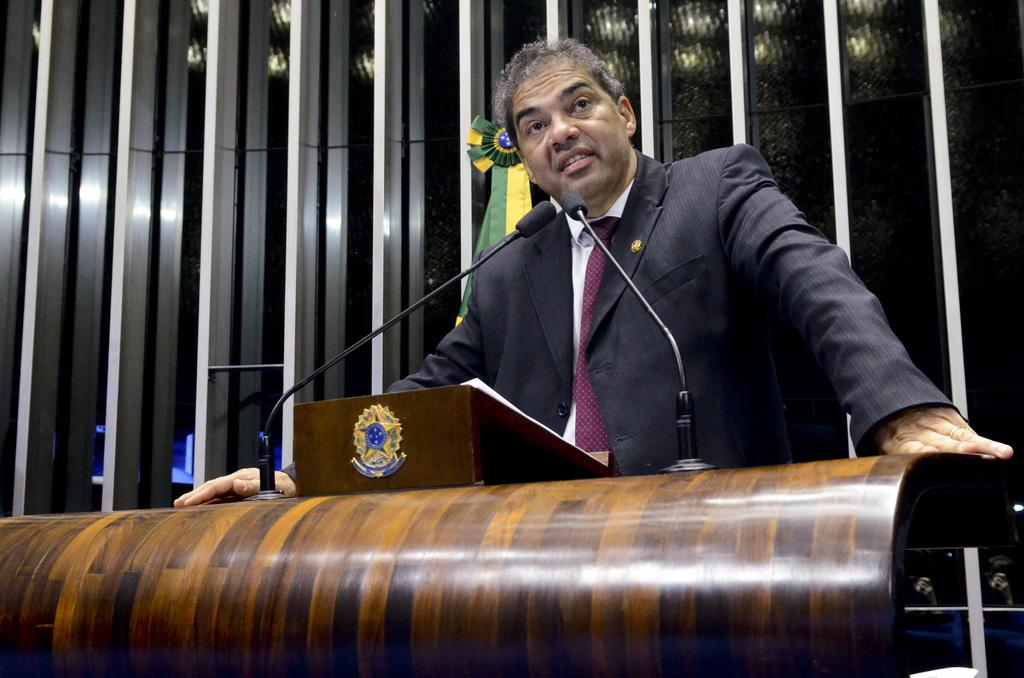What is the person in the image doing near the podium? The person is standing near a podium in the image. What can be seen in the background of the image? There is a wall in the background of the image. What type of butter is being used to paint the wall in the image? There is no butter present in the image, and the wall does not appear to be painted. 